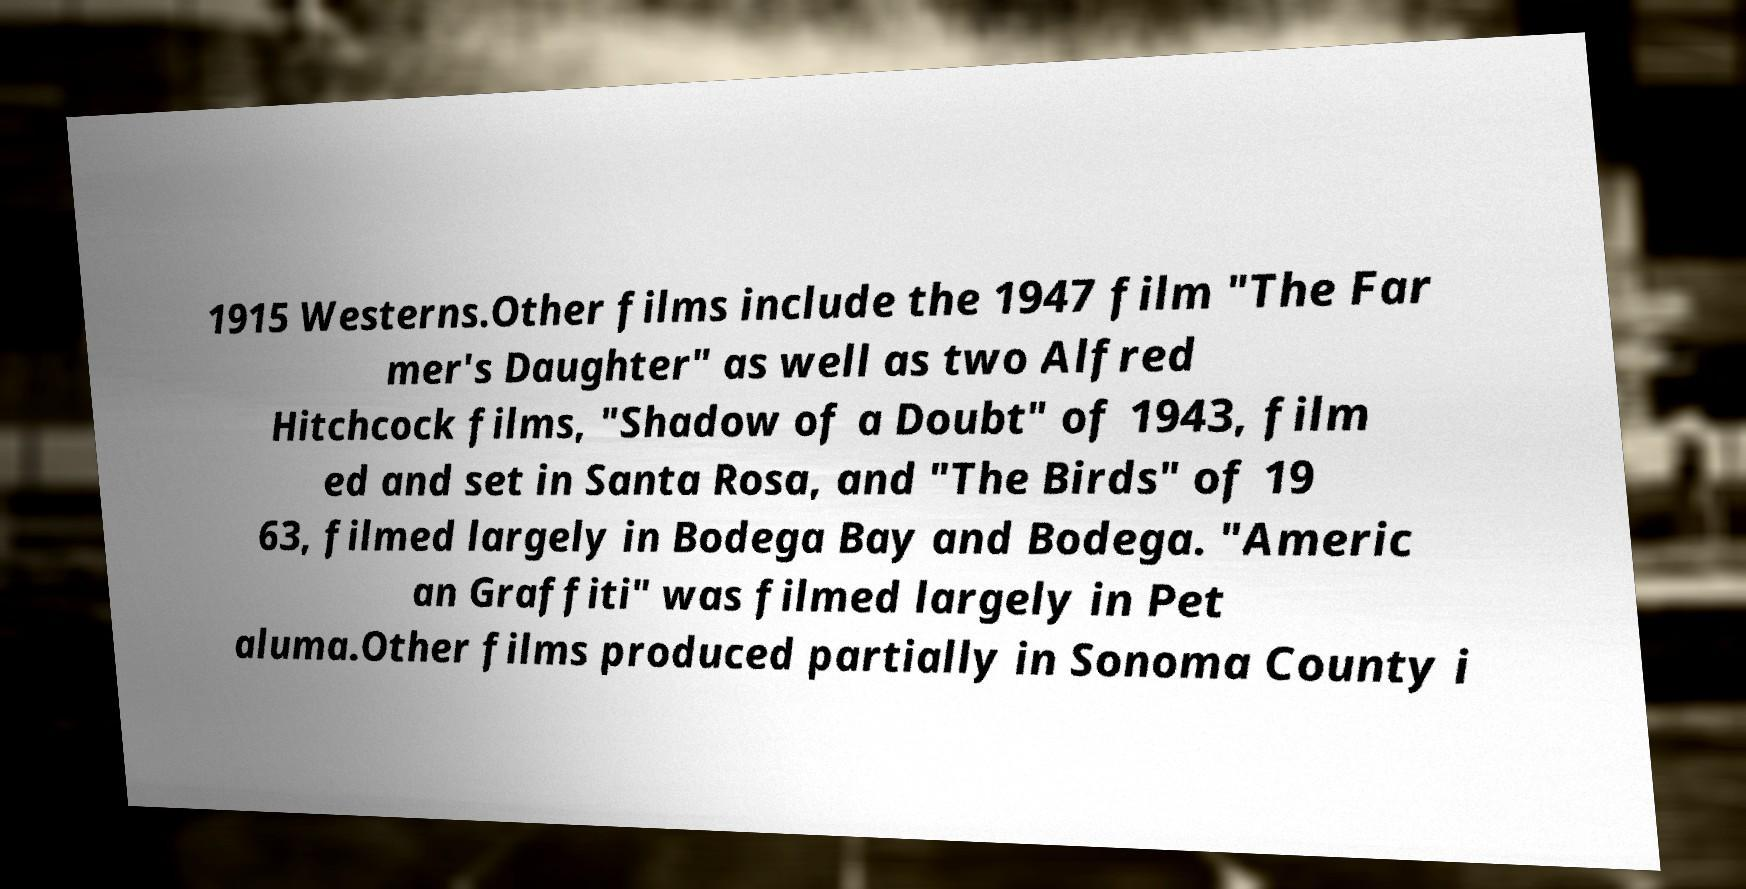I need the written content from this picture converted into text. Can you do that? 1915 Westerns.Other films include the 1947 film "The Far mer's Daughter" as well as two Alfred Hitchcock films, "Shadow of a Doubt" of 1943, film ed and set in Santa Rosa, and "The Birds" of 19 63, filmed largely in Bodega Bay and Bodega. "Americ an Graffiti" was filmed largely in Pet aluma.Other films produced partially in Sonoma County i 